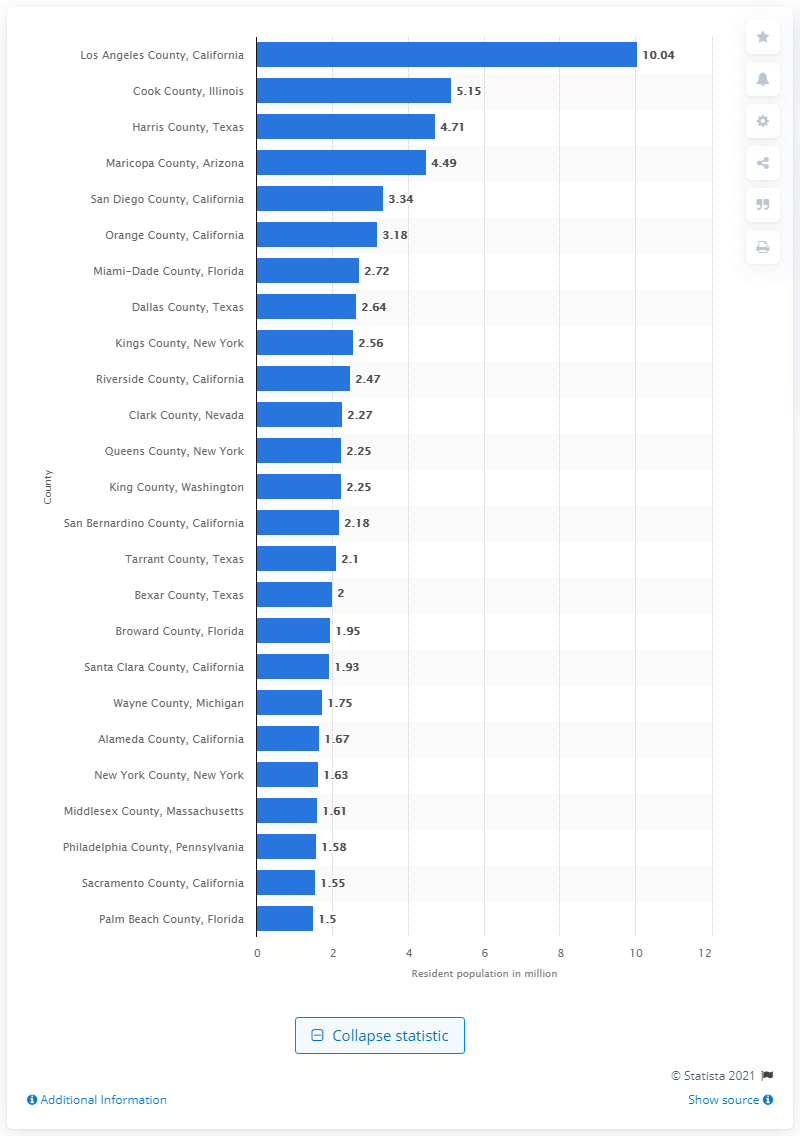Point out several critical features in this image. In 2019, there were approximately 10.04 million people living in Los Angeles County. 